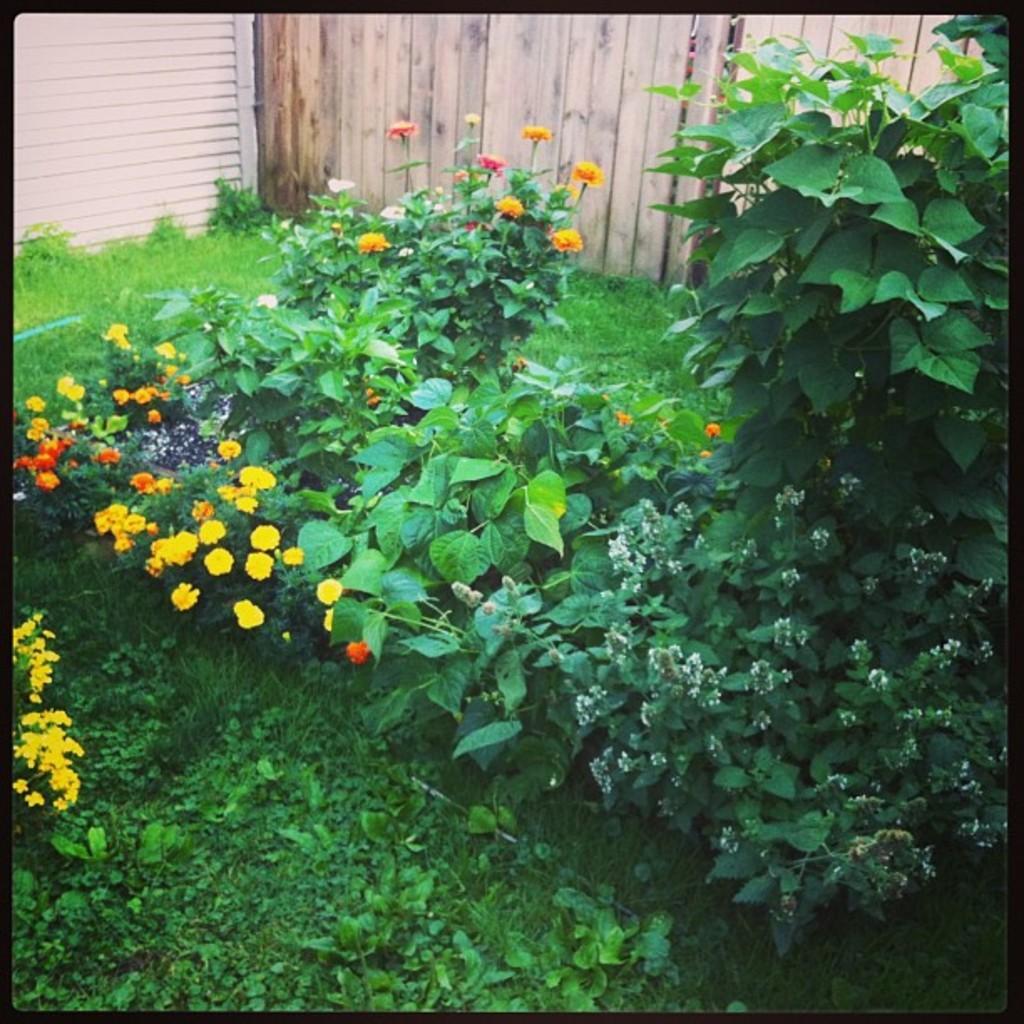Can you describe this image briefly? In this image, we can see plants and flowers. In the background, there is a fence. 